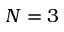Convert formula to latex. <formula><loc_0><loc_0><loc_500><loc_500>N = 3</formula> 